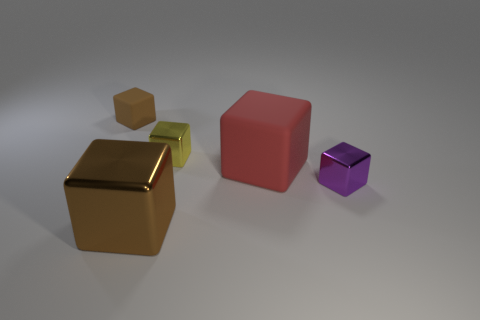There is a object that is the same color as the small matte cube; what is its shape?
Your answer should be compact. Cube. How many rubber objects are either big brown objects or small purple balls?
Provide a short and direct response. 0. There is a matte block behind the tiny yellow block behind the rubber object to the right of the small matte thing; what is its color?
Your response must be concise. Brown. What is the color of the other matte object that is the same shape as the big red rubber thing?
Your answer should be very brief. Brown. Is there anything else that is the same color as the large rubber object?
Ensure brevity in your answer.  No. How many other things are there of the same material as the tiny yellow thing?
Offer a terse response. 2. The brown metallic cube has what size?
Provide a short and direct response. Large. Is there a small brown thing that has the same shape as the large brown shiny thing?
Keep it short and to the point. Yes. How many things are either tiny yellow metallic blocks or brown blocks in front of the tiny purple metal cube?
Give a very brief answer. 2. The matte object right of the brown metallic cube is what color?
Keep it short and to the point. Red. 